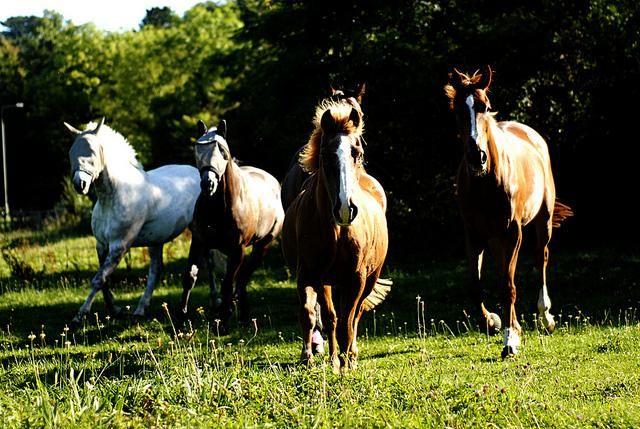These animals are known to do what?

Choices:
A) hibernate
B) gallop
C) fly
D) swim gallop 